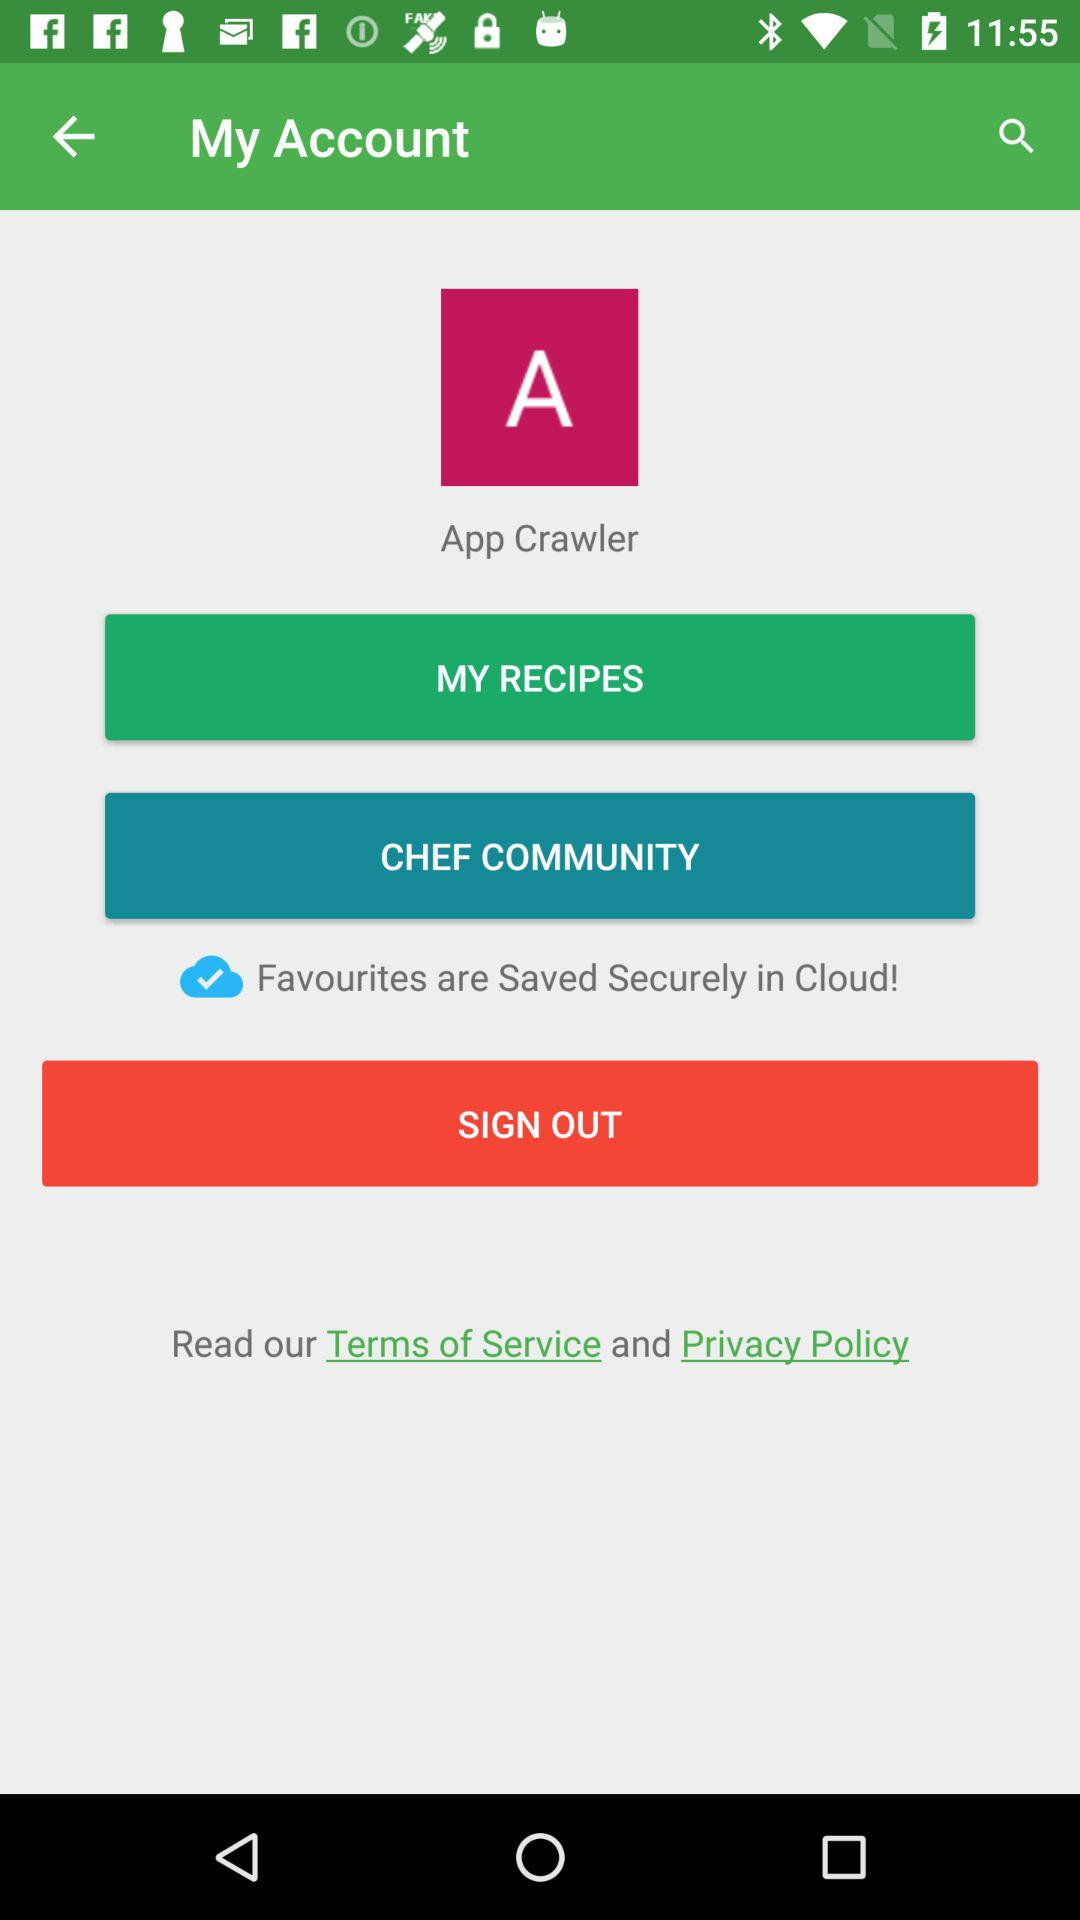Which recipes are saved in "MY RECIPES"?
When the provided information is insufficient, respond with <no answer>. <no answer> 